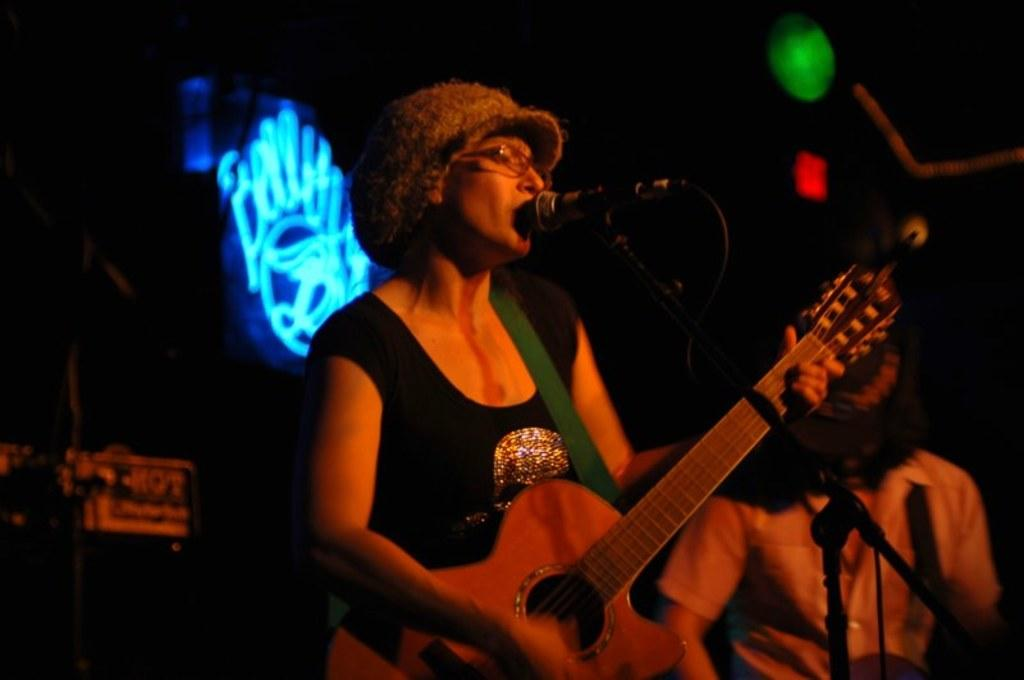What is the woman in the image doing? The woman is standing and playing a guitar, and she is also singing with the help of a microphone. Can you describe the man standing nearby? There is a man standing nearby, but no specific details about him are provided. What can be seen in the image that provides light? There is a light visible in the image. How does the woman's mind help her cry in the image? There is no mention of the woman crying or her mind in the image. The image shows her playing a guitar and singing with a microphone. 